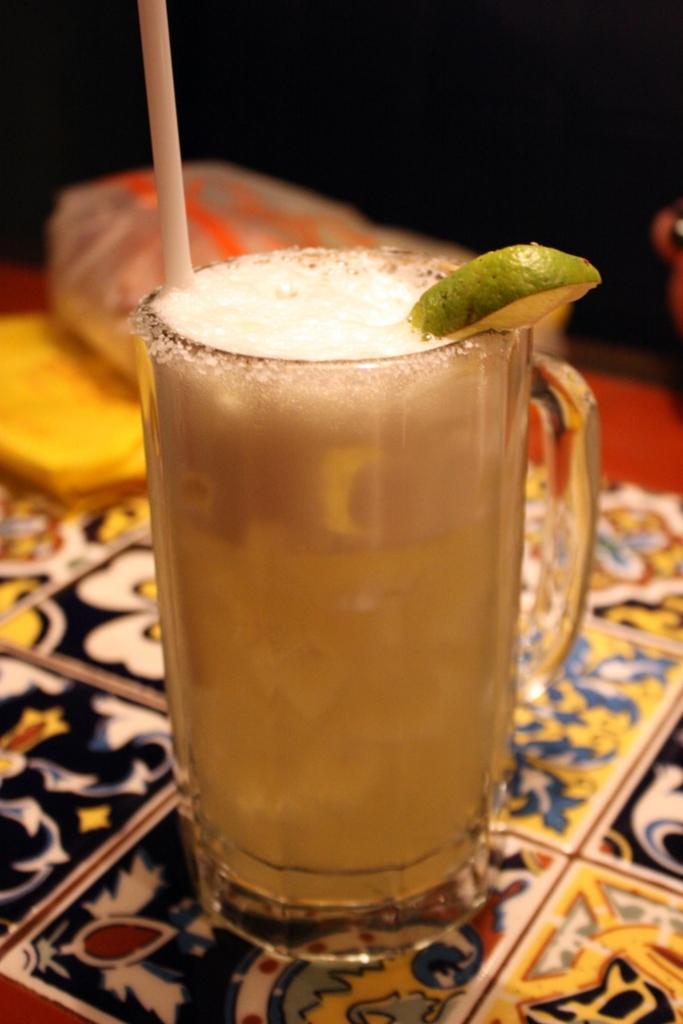Could you give a brief overview of what you see in this image? In this image I can see a red colored surface and on it I can see a cloth, a glass with juice, a lemon and a straw in it and on the surface I can see few other objects and I can see the dark background. 